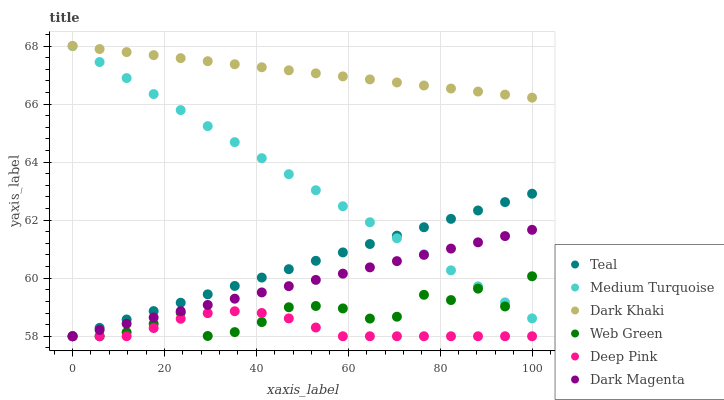Does Deep Pink have the minimum area under the curve?
Answer yes or no. Yes. Does Dark Khaki have the maximum area under the curve?
Answer yes or no. Yes. Does Dark Magenta have the minimum area under the curve?
Answer yes or no. No. Does Dark Magenta have the maximum area under the curve?
Answer yes or no. No. Is Dark Magenta the smoothest?
Answer yes or no. Yes. Is Web Green the roughest?
Answer yes or no. Yes. Is Deep Pink the smoothest?
Answer yes or no. No. Is Deep Pink the roughest?
Answer yes or no. No. Does Teal have the lowest value?
Answer yes or no. Yes. Does Dark Khaki have the lowest value?
Answer yes or no. No. Does Medium Turquoise have the highest value?
Answer yes or no. Yes. Does Dark Magenta have the highest value?
Answer yes or no. No. Is Dark Magenta less than Dark Khaki?
Answer yes or no. Yes. Is Dark Khaki greater than Web Green?
Answer yes or no. Yes. Does Teal intersect Medium Turquoise?
Answer yes or no. Yes. Is Teal less than Medium Turquoise?
Answer yes or no. No. Is Teal greater than Medium Turquoise?
Answer yes or no. No. Does Dark Magenta intersect Dark Khaki?
Answer yes or no. No. 